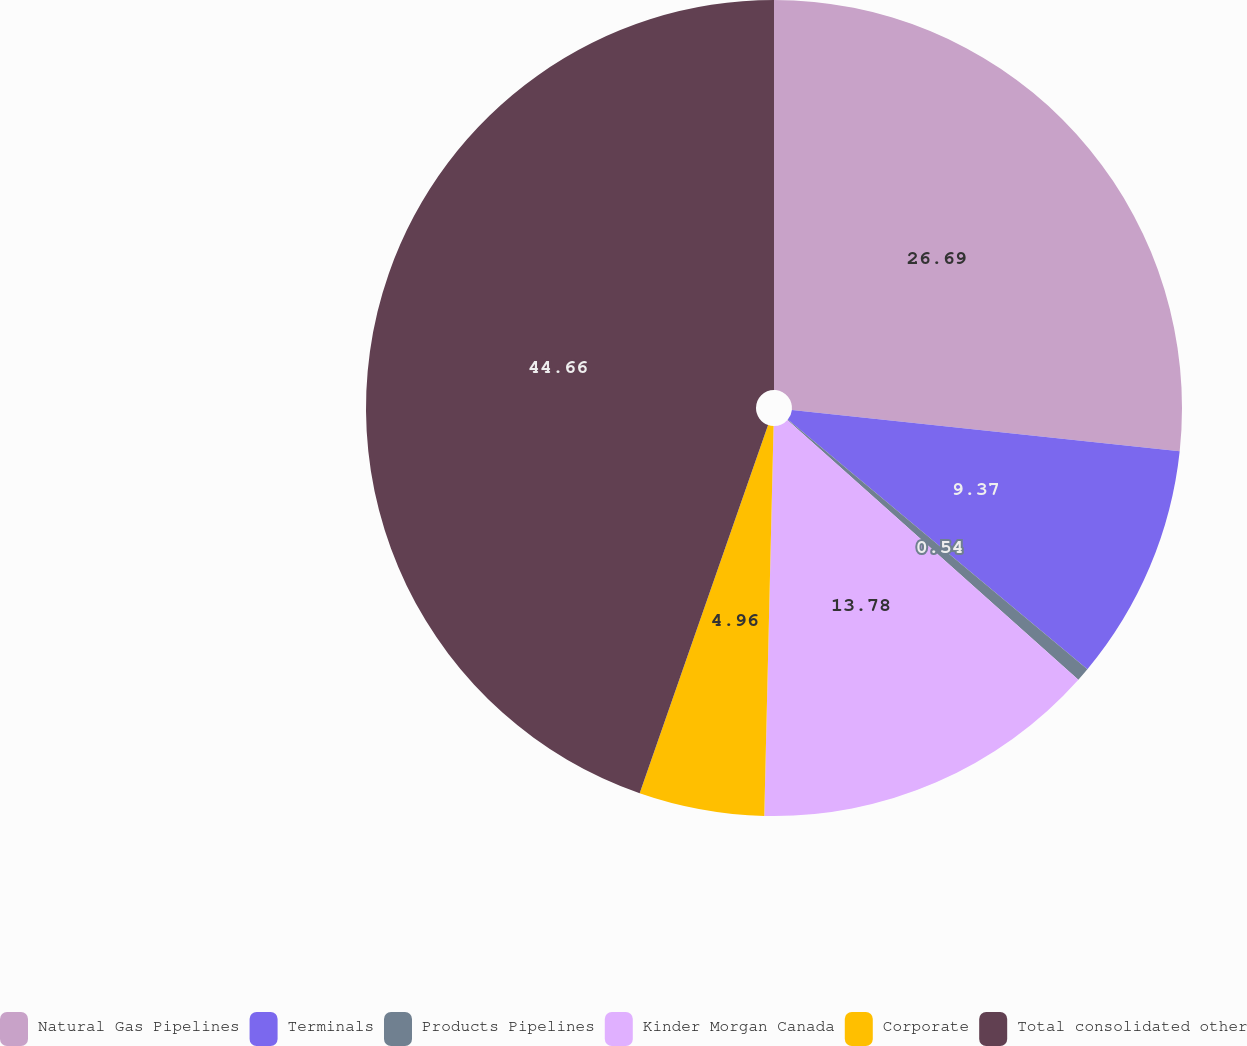<chart> <loc_0><loc_0><loc_500><loc_500><pie_chart><fcel>Natural Gas Pipelines<fcel>Terminals<fcel>Products Pipelines<fcel>Kinder Morgan Canada<fcel>Corporate<fcel>Total consolidated other<nl><fcel>26.69%<fcel>9.37%<fcel>0.54%<fcel>13.78%<fcel>4.96%<fcel>44.66%<nl></chart> 